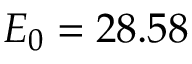Convert formula to latex. <formula><loc_0><loc_0><loc_500><loc_500>E _ { 0 } = 2 8 . 5 8</formula> 